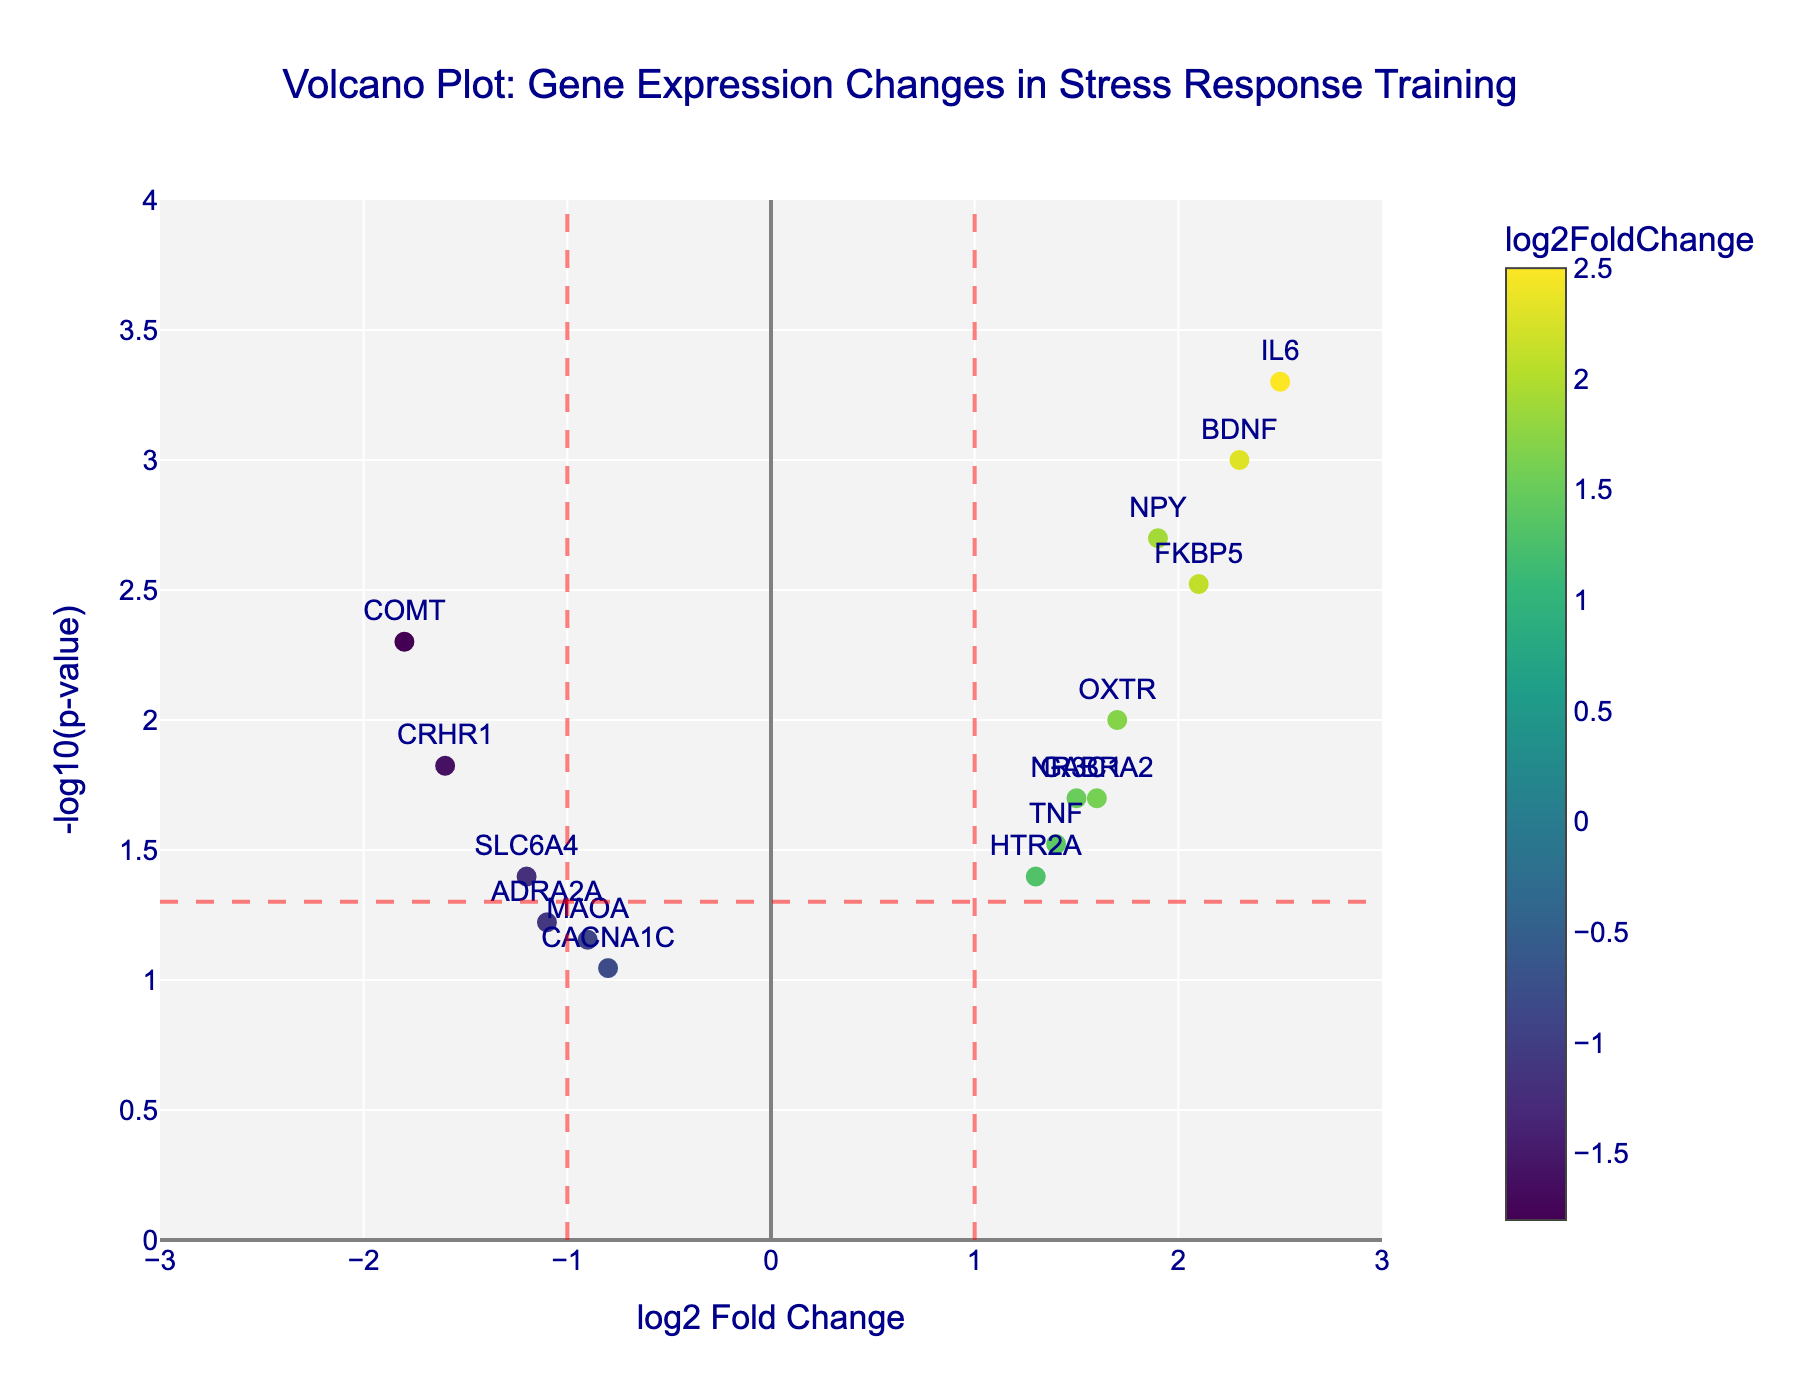Which gene has the highest log2 fold change? By examining the x-axis, the gene with the highest log2 fold change is the one furthest to the right. In this case, it is IL6.
Answer: IL6 What is the p-value threshold indicated by the horizontal red dashed line? The horizontal red dashed line represents the significance threshold of 0.05. The y-coordinate of this line is -log10(0.05).
Answer: 0.05 Are there more genes with positive or negative log2 fold change values? Count the number of genes on the right side (positive) and the left side (negative) of the vertical line at log2 fold change = 0. There are 9 genes with positive log2 fold changes and 6 with negative.
Answer: Positive Which gene has the lowest p-value? The gene with the highest -log10(p-value) corresponds to the lowest p-value. In this case, it is IL6.
Answer: IL6 Which gene has the lowest log2 fold change? By examining the x-axis, the gene with the lowest log2 fold change is the one furthest to the left. In this case, it is COMT.
Answer: COMT How many genes have log2 fold changes greater than 1 and also have p-values less than 0.05? Look for genes to the right of the vertical line at log2 fold change = 1 and above the horizontal line at -log10(p-value) ≈ 1.301. The genes are BDNF, FKBP5, IL6, GABRA2, and OXTR. That's 5 genes.
Answer: 5 Which gene shows a log2 fold change closest to 0 but still significant (p-value < 0.05)? Examine the genes that are above the horizontal significance line and find the one closest to the vertical line at log2 fold change = 0. HTR2A is closest.
Answer: HTR2A What is the log2 fold change range represented on the plot? The x-axis covers the range from -3 to 3. This can be seen from the axis limits.
Answer: -3 to 3 Are there any genes with non-significant p-values and a log2 fold change less than -1? Check for genes with -log10(p-value) below the red horizontal line and to the left of the red vertical line at -1. Two such genes are MAOA and ADRA2A.
Answer: Yes What color is used to represent the log2 fold change on the plot? The data points use a colorscale (Viridis) to represent log2 fold change.
Answer: Colorscale (Viridis) 